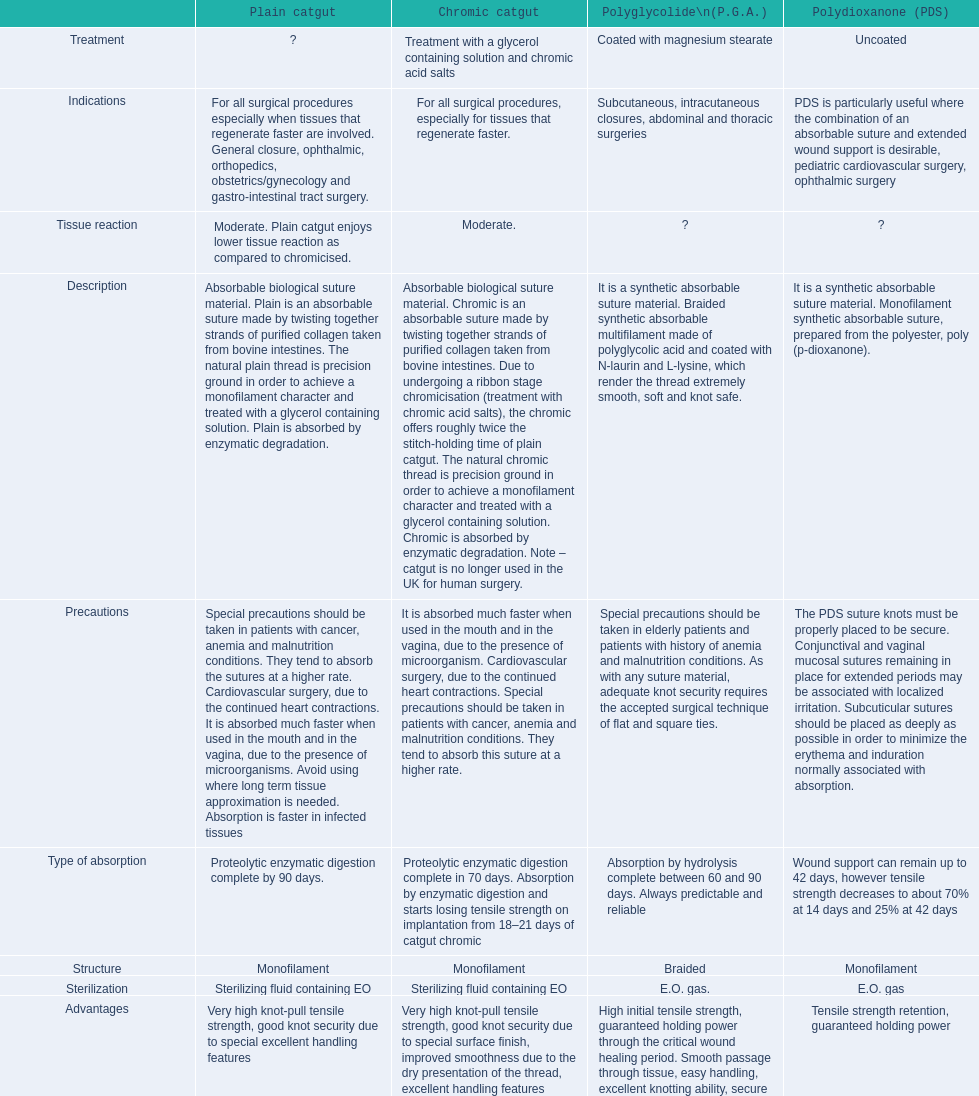What type of sutures are no longer used in the u.k. for human surgery? Chromic catgut. 